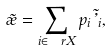<formula> <loc_0><loc_0><loc_500><loc_500>\tilde { \rho } = \sum _ { i \in \ r X } p _ { i } \tilde { \varphi } _ { i } ,</formula> 